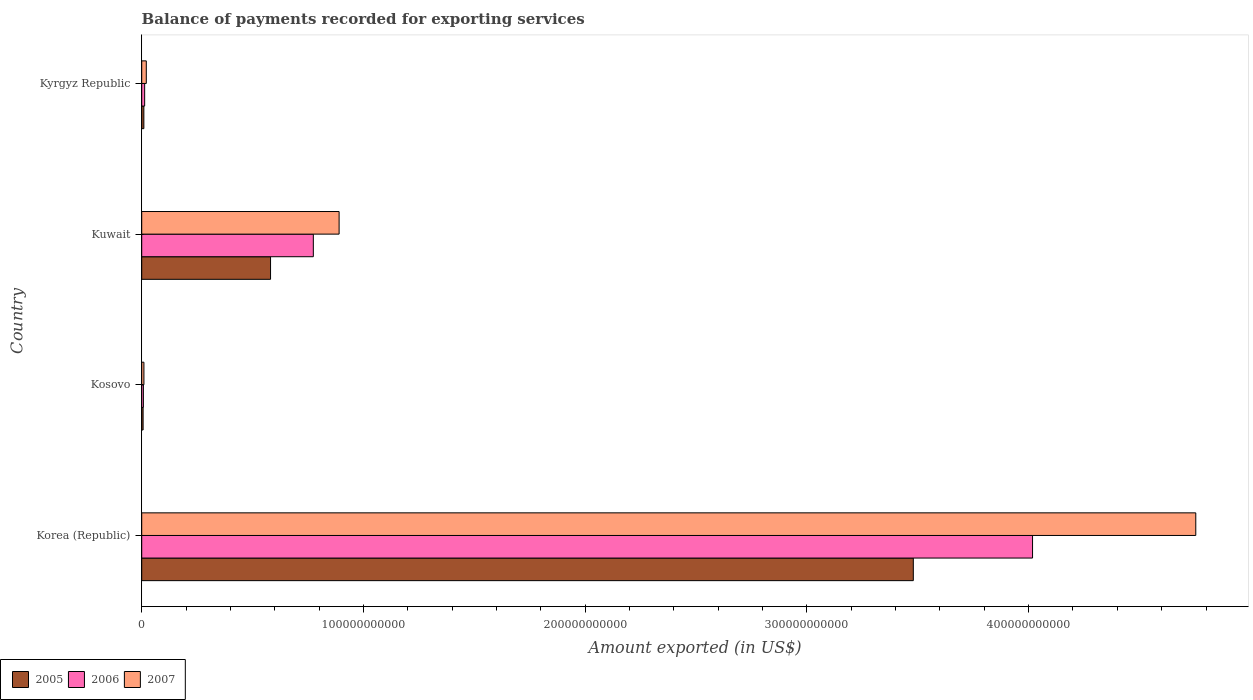How many different coloured bars are there?
Your answer should be very brief. 3. How many groups of bars are there?
Make the answer very short. 4. Are the number of bars on each tick of the Y-axis equal?
Give a very brief answer. Yes. How many bars are there on the 3rd tick from the top?
Your answer should be very brief. 3. How many bars are there on the 3rd tick from the bottom?
Offer a very short reply. 3. What is the label of the 1st group of bars from the top?
Give a very brief answer. Kyrgyz Republic. In how many cases, is the number of bars for a given country not equal to the number of legend labels?
Offer a terse response. 0. What is the amount exported in 2007 in Kosovo?
Offer a very short reply. 9.91e+08. Across all countries, what is the maximum amount exported in 2005?
Keep it short and to the point. 3.48e+11. Across all countries, what is the minimum amount exported in 2006?
Your response must be concise. 7.50e+08. In which country was the amount exported in 2007 minimum?
Keep it short and to the point. Kosovo. What is the total amount exported in 2005 in the graph?
Your response must be concise. 4.08e+11. What is the difference between the amount exported in 2006 in Kosovo and that in Kyrgyz Republic?
Offer a very short reply. -5.76e+08. What is the difference between the amount exported in 2005 in Kyrgyz Republic and the amount exported in 2006 in Korea (Republic)?
Provide a short and direct response. -4.01e+11. What is the average amount exported in 2007 per country?
Ensure brevity in your answer.  1.42e+11. What is the difference between the amount exported in 2006 and amount exported in 2005 in Kosovo?
Offer a very short reply. 1.26e+08. In how many countries, is the amount exported in 2007 greater than 380000000000 US$?
Your response must be concise. 1. What is the ratio of the amount exported in 2005 in Kuwait to that in Kyrgyz Republic?
Provide a succinct answer. 60.35. Is the amount exported in 2005 in Korea (Republic) less than that in Kyrgyz Republic?
Your answer should be compact. No. Is the difference between the amount exported in 2006 in Kosovo and Kyrgyz Republic greater than the difference between the amount exported in 2005 in Kosovo and Kyrgyz Republic?
Your response must be concise. No. What is the difference between the highest and the second highest amount exported in 2007?
Provide a short and direct response. 3.86e+11. What is the difference between the highest and the lowest amount exported in 2006?
Offer a very short reply. 4.01e+11. What does the 1st bar from the bottom in Kuwait represents?
Give a very brief answer. 2005. How many bars are there?
Provide a succinct answer. 12. How many countries are there in the graph?
Your answer should be very brief. 4. What is the difference between two consecutive major ticks on the X-axis?
Offer a terse response. 1.00e+11. Does the graph contain any zero values?
Offer a very short reply. No. How many legend labels are there?
Your response must be concise. 3. What is the title of the graph?
Provide a succinct answer. Balance of payments recorded for exporting services. What is the label or title of the X-axis?
Keep it short and to the point. Amount exported (in US$). What is the Amount exported (in US$) in 2005 in Korea (Republic)?
Offer a very short reply. 3.48e+11. What is the Amount exported (in US$) of 2006 in Korea (Republic)?
Offer a terse response. 4.02e+11. What is the Amount exported (in US$) in 2007 in Korea (Republic)?
Give a very brief answer. 4.75e+11. What is the Amount exported (in US$) of 2005 in Kosovo?
Provide a succinct answer. 6.25e+08. What is the Amount exported (in US$) in 2006 in Kosovo?
Ensure brevity in your answer.  7.50e+08. What is the Amount exported (in US$) in 2007 in Kosovo?
Offer a very short reply. 9.91e+08. What is the Amount exported (in US$) of 2005 in Kuwait?
Provide a short and direct response. 5.81e+1. What is the Amount exported (in US$) in 2006 in Kuwait?
Provide a short and direct response. 7.74e+1. What is the Amount exported (in US$) of 2007 in Kuwait?
Offer a very short reply. 8.90e+1. What is the Amount exported (in US$) of 2005 in Kyrgyz Republic?
Provide a succinct answer. 9.63e+08. What is the Amount exported (in US$) in 2006 in Kyrgyz Republic?
Your answer should be compact. 1.33e+09. What is the Amount exported (in US$) of 2007 in Kyrgyz Republic?
Offer a very short reply. 2.07e+09. Across all countries, what is the maximum Amount exported (in US$) in 2005?
Provide a succinct answer. 3.48e+11. Across all countries, what is the maximum Amount exported (in US$) of 2006?
Your response must be concise. 4.02e+11. Across all countries, what is the maximum Amount exported (in US$) in 2007?
Keep it short and to the point. 4.75e+11. Across all countries, what is the minimum Amount exported (in US$) in 2005?
Provide a succinct answer. 6.25e+08. Across all countries, what is the minimum Amount exported (in US$) in 2006?
Keep it short and to the point. 7.50e+08. Across all countries, what is the minimum Amount exported (in US$) in 2007?
Offer a very short reply. 9.91e+08. What is the total Amount exported (in US$) of 2005 in the graph?
Your answer should be very brief. 4.08e+11. What is the total Amount exported (in US$) in 2006 in the graph?
Provide a succinct answer. 4.81e+11. What is the total Amount exported (in US$) in 2007 in the graph?
Keep it short and to the point. 5.67e+11. What is the difference between the Amount exported (in US$) in 2005 in Korea (Republic) and that in Kosovo?
Offer a terse response. 3.47e+11. What is the difference between the Amount exported (in US$) of 2006 in Korea (Republic) and that in Kosovo?
Ensure brevity in your answer.  4.01e+11. What is the difference between the Amount exported (in US$) in 2007 in Korea (Republic) and that in Kosovo?
Make the answer very short. 4.74e+11. What is the difference between the Amount exported (in US$) of 2005 in Korea (Republic) and that in Kuwait?
Provide a succinct answer. 2.90e+11. What is the difference between the Amount exported (in US$) in 2006 in Korea (Republic) and that in Kuwait?
Keep it short and to the point. 3.24e+11. What is the difference between the Amount exported (in US$) in 2007 in Korea (Republic) and that in Kuwait?
Keep it short and to the point. 3.86e+11. What is the difference between the Amount exported (in US$) of 2005 in Korea (Republic) and that in Kyrgyz Republic?
Offer a very short reply. 3.47e+11. What is the difference between the Amount exported (in US$) in 2006 in Korea (Republic) and that in Kyrgyz Republic?
Your answer should be compact. 4.00e+11. What is the difference between the Amount exported (in US$) of 2007 in Korea (Republic) and that in Kyrgyz Republic?
Offer a terse response. 4.73e+11. What is the difference between the Amount exported (in US$) of 2005 in Kosovo and that in Kuwait?
Make the answer very short. -5.75e+1. What is the difference between the Amount exported (in US$) of 2006 in Kosovo and that in Kuwait?
Offer a very short reply. -7.66e+1. What is the difference between the Amount exported (in US$) of 2007 in Kosovo and that in Kuwait?
Make the answer very short. -8.80e+1. What is the difference between the Amount exported (in US$) of 2005 in Kosovo and that in Kyrgyz Republic?
Make the answer very short. -3.38e+08. What is the difference between the Amount exported (in US$) in 2006 in Kosovo and that in Kyrgyz Republic?
Provide a short and direct response. -5.76e+08. What is the difference between the Amount exported (in US$) of 2007 in Kosovo and that in Kyrgyz Republic?
Offer a terse response. -1.07e+09. What is the difference between the Amount exported (in US$) of 2005 in Kuwait and that in Kyrgyz Republic?
Your answer should be compact. 5.71e+1. What is the difference between the Amount exported (in US$) in 2006 in Kuwait and that in Kyrgyz Republic?
Make the answer very short. 7.61e+1. What is the difference between the Amount exported (in US$) of 2007 in Kuwait and that in Kyrgyz Republic?
Offer a terse response. 8.70e+1. What is the difference between the Amount exported (in US$) in 2005 in Korea (Republic) and the Amount exported (in US$) in 2006 in Kosovo?
Keep it short and to the point. 3.47e+11. What is the difference between the Amount exported (in US$) in 2005 in Korea (Republic) and the Amount exported (in US$) in 2007 in Kosovo?
Your answer should be compact. 3.47e+11. What is the difference between the Amount exported (in US$) of 2006 in Korea (Republic) and the Amount exported (in US$) of 2007 in Kosovo?
Your response must be concise. 4.01e+11. What is the difference between the Amount exported (in US$) in 2005 in Korea (Republic) and the Amount exported (in US$) in 2006 in Kuwait?
Make the answer very short. 2.71e+11. What is the difference between the Amount exported (in US$) of 2005 in Korea (Republic) and the Amount exported (in US$) of 2007 in Kuwait?
Your response must be concise. 2.59e+11. What is the difference between the Amount exported (in US$) of 2006 in Korea (Republic) and the Amount exported (in US$) of 2007 in Kuwait?
Offer a terse response. 3.13e+11. What is the difference between the Amount exported (in US$) of 2005 in Korea (Republic) and the Amount exported (in US$) of 2006 in Kyrgyz Republic?
Provide a succinct answer. 3.47e+11. What is the difference between the Amount exported (in US$) in 2005 in Korea (Republic) and the Amount exported (in US$) in 2007 in Kyrgyz Republic?
Give a very brief answer. 3.46e+11. What is the difference between the Amount exported (in US$) in 2006 in Korea (Republic) and the Amount exported (in US$) in 2007 in Kyrgyz Republic?
Ensure brevity in your answer.  4.00e+11. What is the difference between the Amount exported (in US$) in 2005 in Kosovo and the Amount exported (in US$) in 2006 in Kuwait?
Offer a terse response. -7.68e+1. What is the difference between the Amount exported (in US$) of 2005 in Kosovo and the Amount exported (in US$) of 2007 in Kuwait?
Provide a succinct answer. -8.84e+1. What is the difference between the Amount exported (in US$) in 2006 in Kosovo and the Amount exported (in US$) in 2007 in Kuwait?
Your response must be concise. -8.83e+1. What is the difference between the Amount exported (in US$) in 2005 in Kosovo and the Amount exported (in US$) in 2006 in Kyrgyz Republic?
Your response must be concise. -7.02e+08. What is the difference between the Amount exported (in US$) of 2005 in Kosovo and the Amount exported (in US$) of 2007 in Kyrgyz Republic?
Your answer should be very brief. -1.44e+09. What is the difference between the Amount exported (in US$) in 2006 in Kosovo and the Amount exported (in US$) in 2007 in Kyrgyz Republic?
Keep it short and to the point. -1.31e+09. What is the difference between the Amount exported (in US$) of 2005 in Kuwait and the Amount exported (in US$) of 2006 in Kyrgyz Republic?
Give a very brief answer. 5.68e+1. What is the difference between the Amount exported (in US$) of 2005 in Kuwait and the Amount exported (in US$) of 2007 in Kyrgyz Republic?
Make the answer very short. 5.60e+1. What is the difference between the Amount exported (in US$) of 2006 in Kuwait and the Amount exported (in US$) of 2007 in Kyrgyz Republic?
Give a very brief answer. 7.53e+1. What is the average Amount exported (in US$) of 2005 per country?
Your answer should be very brief. 1.02e+11. What is the average Amount exported (in US$) of 2006 per country?
Ensure brevity in your answer.  1.20e+11. What is the average Amount exported (in US$) of 2007 per country?
Your response must be concise. 1.42e+11. What is the difference between the Amount exported (in US$) in 2005 and Amount exported (in US$) in 2006 in Korea (Republic)?
Provide a succinct answer. -5.38e+1. What is the difference between the Amount exported (in US$) of 2005 and Amount exported (in US$) of 2007 in Korea (Republic)?
Keep it short and to the point. -1.27e+11. What is the difference between the Amount exported (in US$) of 2006 and Amount exported (in US$) of 2007 in Korea (Republic)?
Your answer should be compact. -7.36e+1. What is the difference between the Amount exported (in US$) in 2005 and Amount exported (in US$) in 2006 in Kosovo?
Your response must be concise. -1.26e+08. What is the difference between the Amount exported (in US$) in 2005 and Amount exported (in US$) in 2007 in Kosovo?
Ensure brevity in your answer.  -3.66e+08. What is the difference between the Amount exported (in US$) in 2006 and Amount exported (in US$) in 2007 in Kosovo?
Offer a very short reply. -2.40e+08. What is the difference between the Amount exported (in US$) of 2005 and Amount exported (in US$) of 2006 in Kuwait?
Ensure brevity in your answer.  -1.93e+1. What is the difference between the Amount exported (in US$) of 2005 and Amount exported (in US$) of 2007 in Kuwait?
Provide a succinct answer. -3.09e+1. What is the difference between the Amount exported (in US$) in 2006 and Amount exported (in US$) in 2007 in Kuwait?
Ensure brevity in your answer.  -1.16e+1. What is the difference between the Amount exported (in US$) in 2005 and Amount exported (in US$) in 2006 in Kyrgyz Republic?
Your response must be concise. -3.64e+08. What is the difference between the Amount exported (in US$) of 2005 and Amount exported (in US$) of 2007 in Kyrgyz Republic?
Give a very brief answer. -1.10e+09. What is the difference between the Amount exported (in US$) in 2006 and Amount exported (in US$) in 2007 in Kyrgyz Republic?
Your answer should be very brief. -7.39e+08. What is the ratio of the Amount exported (in US$) of 2005 in Korea (Republic) to that in Kosovo?
Give a very brief answer. 556.95. What is the ratio of the Amount exported (in US$) in 2006 in Korea (Republic) to that in Kosovo?
Provide a succinct answer. 535.36. What is the ratio of the Amount exported (in US$) of 2007 in Korea (Republic) to that in Kosovo?
Your answer should be very brief. 479.9. What is the ratio of the Amount exported (in US$) in 2005 in Korea (Republic) to that in Kuwait?
Ensure brevity in your answer.  5.99. What is the ratio of the Amount exported (in US$) of 2006 in Korea (Republic) to that in Kuwait?
Keep it short and to the point. 5.19. What is the ratio of the Amount exported (in US$) in 2007 in Korea (Republic) to that in Kuwait?
Provide a short and direct response. 5.34. What is the ratio of the Amount exported (in US$) of 2005 in Korea (Republic) to that in Kyrgyz Republic?
Keep it short and to the point. 361.44. What is the ratio of the Amount exported (in US$) of 2006 in Korea (Republic) to that in Kyrgyz Republic?
Your answer should be very brief. 302.91. What is the ratio of the Amount exported (in US$) of 2007 in Korea (Republic) to that in Kyrgyz Republic?
Offer a terse response. 230.19. What is the ratio of the Amount exported (in US$) in 2005 in Kosovo to that in Kuwait?
Provide a short and direct response. 0.01. What is the ratio of the Amount exported (in US$) in 2006 in Kosovo to that in Kuwait?
Your answer should be very brief. 0.01. What is the ratio of the Amount exported (in US$) of 2007 in Kosovo to that in Kuwait?
Keep it short and to the point. 0.01. What is the ratio of the Amount exported (in US$) in 2005 in Kosovo to that in Kyrgyz Republic?
Your answer should be very brief. 0.65. What is the ratio of the Amount exported (in US$) in 2006 in Kosovo to that in Kyrgyz Republic?
Give a very brief answer. 0.57. What is the ratio of the Amount exported (in US$) in 2007 in Kosovo to that in Kyrgyz Republic?
Your answer should be very brief. 0.48. What is the ratio of the Amount exported (in US$) in 2005 in Kuwait to that in Kyrgyz Republic?
Keep it short and to the point. 60.35. What is the ratio of the Amount exported (in US$) in 2006 in Kuwait to that in Kyrgyz Republic?
Offer a very short reply. 58.35. What is the ratio of the Amount exported (in US$) in 2007 in Kuwait to that in Kyrgyz Republic?
Your answer should be compact. 43.1. What is the difference between the highest and the second highest Amount exported (in US$) in 2005?
Keep it short and to the point. 2.90e+11. What is the difference between the highest and the second highest Amount exported (in US$) in 2006?
Provide a short and direct response. 3.24e+11. What is the difference between the highest and the second highest Amount exported (in US$) of 2007?
Your answer should be very brief. 3.86e+11. What is the difference between the highest and the lowest Amount exported (in US$) in 2005?
Ensure brevity in your answer.  3.47e+11. What is the difference between the highest and the lowest Amount exported (in US$) of 2006?
Provide a short and direct response. 4.01e+11. What is the difference between the highest and the lowest Amount exported (in US$) in 2007?
Offer a terse response. 4.74e+11. 